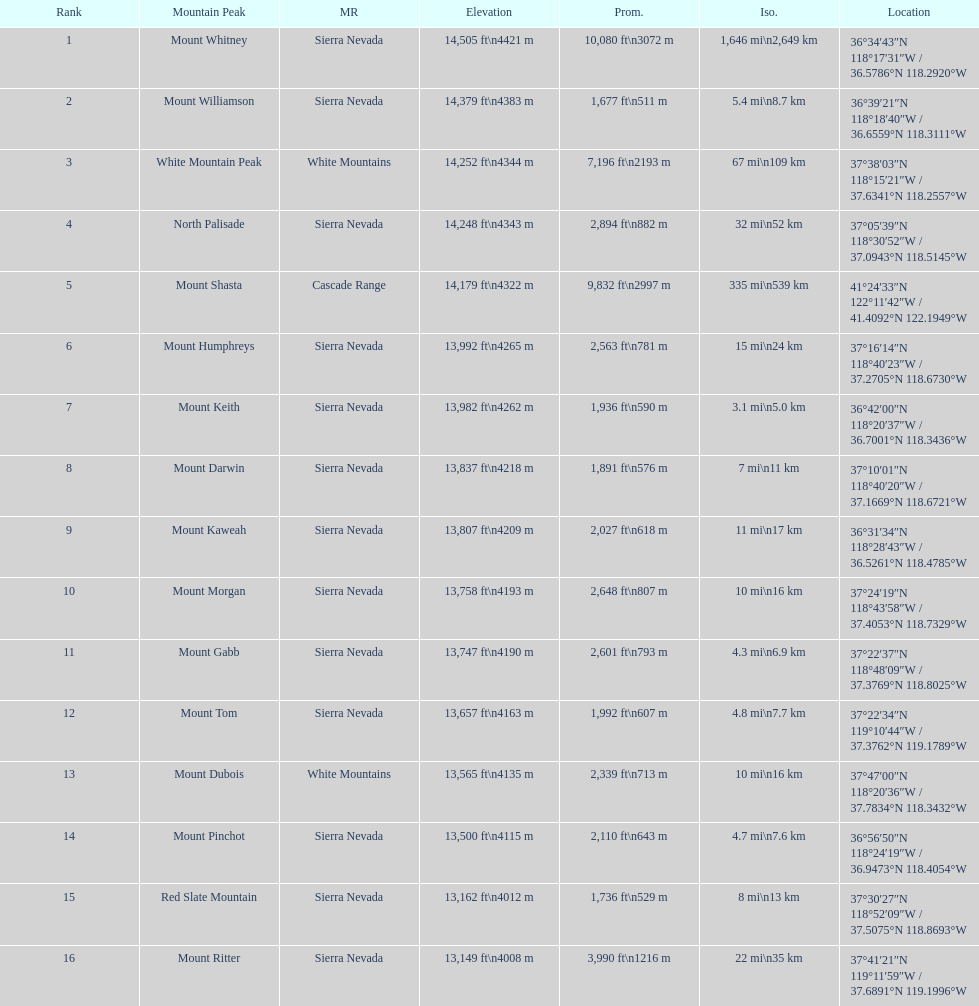What is the next highest mountain peak after north palisade? Mount Shasta. 